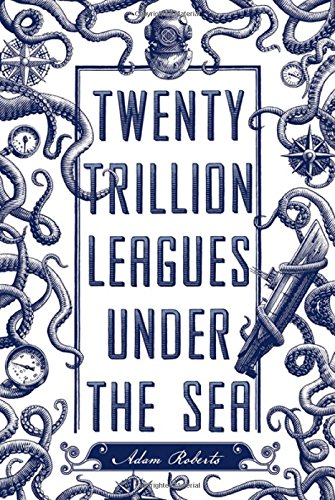Who wrote this book?
Answer the question using a single word or phrase. Adam Roberts What is the title of this book? Twenty Trillion Leagues Under the Sea What is the genre of this book? Science Fiction & Fantasy Is this a sci-fi book? Yes Is this a journey related book? No 